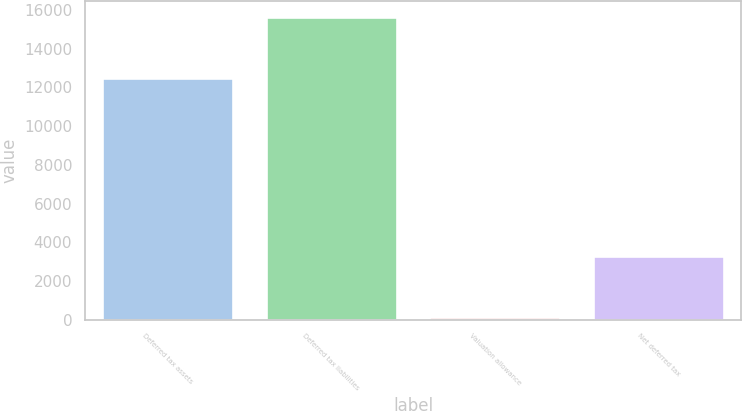<chart> <loc_0><loc_0><loc_500><loc_500><bar_chart><fcel>Deferred tax assets<fcel>Deferred tax liabilities<fcel>Valuation allowance<fcel>Net deferred tax<nl><fcel>12486<fcel>15664<fcel>125<fcel>3303<nl></chart> 